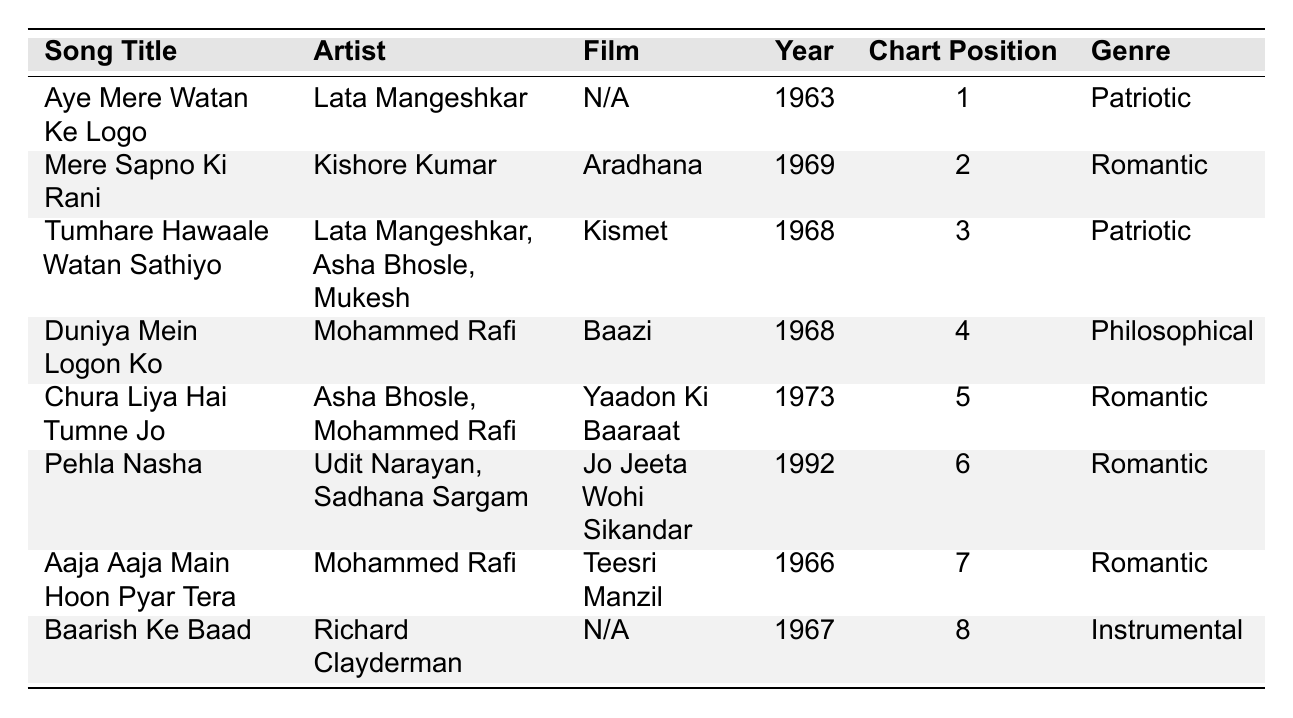What is the highest chart position achieved by a song in 1963? Referring to the table, "Aye Mere Watan Ke Logo" was released in 1963 and holds the chart position of 1, which is the highest in that year.
Answer: 1 Who is the artist of the song "Mere Sapno Ki Rani"? The table lists that the song "Mere Sapno Ki Rani" was performed by Kishore Kumar.
Answer: Kishore Kumar How many songs in the table are categorized under the Romantic genre? The table shows that "Mere Sapno Ki Rani," "Chura Liya Hai Tumne Jo," "Pehla Nasha," and "Aaja Aaja Main Hoon Pyar Tera" are under the Romantic genre, totaling 4 songs.
Answer: 4 Are there any songs that were released in 1968? If so, how many? By checking the table, "Tumhare Hawaale Watan Sathiyo" and "Duniya Mein Logon Ko" were both released in 1968. Thus, there are 2 songs from that year.
Answer: Yes, 2 Is "Aaja Aaja Main Hoon Pyar Tera" ranked higher than "Duniya Mein Logon Ko"? The table displays that "Duniya Mein Logon Ko" has a chart position of 4, while "Aaja Aaja Main Hoon Pyar Tera" is ranked 7. Since 4 is higher than 7, "Aaja Aaja Main Hoon Pyar Tera" is not ranked higher.
Answer: No What is the average chart position of the songs listed? Summing the chart positions gives 1 + 2 + 3 + 4 + 5 + 6 + 7 + 8 = 36. Since there are 8 songs, the average is 36/8 = 4.5.
Answer: 4.5 Which song has the lowest chart position and what is its genre? Looking through the table, "Baarish Ke Baad" has the lowest chart position of 8, and its genre is Instrumental.
Answer: Baarish Ke Baad, Instrumental Was "Aye Mere Watan Ke Logo" released in a film? The table indicates that "Aye Mere Watan Ke Logo" has "N/A" listed for the film, meaning it was not featured in a film.
Answer: No Which song features multiple artists and what are their names? The song "Tumhare Hawaale Watan Sathiyo" features Lata Mangeshkar, Asha Bhosle, and Mukesh as artists.
Answer: Lata Mangeshkar, Asha Bhosle, Mukesh How many years apart were the releases of "Aye Mere Watan Ke Logo" and "Mere Sapno Ki Rani"? "Aye Mere Watan Ke Logo" was released in 1963 and "Mere Sapno Ki Rani" in 1969. The difference is 1969 - 1963 = 6 years.
Answer: 6 years 